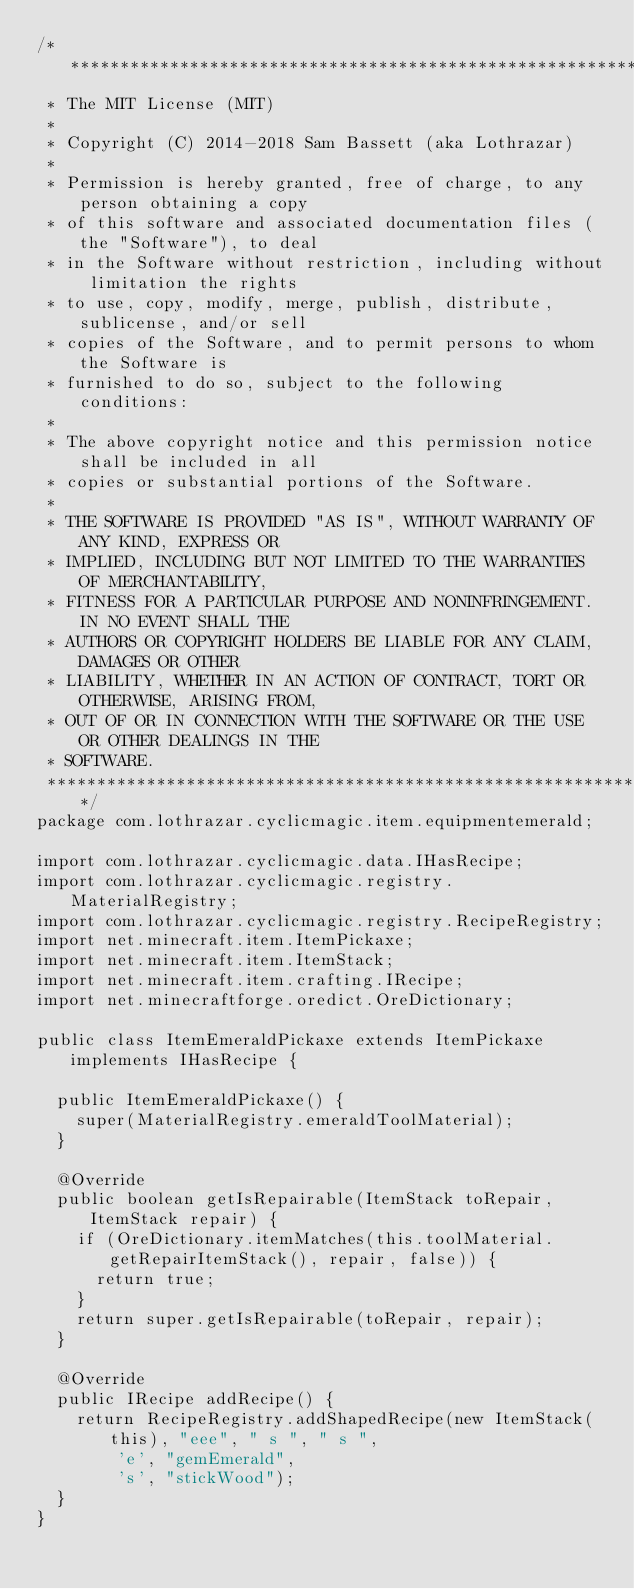Convert code to text. <code><loc_0><loc_0><loc_500><loc_500><_Java_>/*******************************************************************************
 * The MIT License (MIT)
 * 
 * Copyright (C) 2014-2018 Sam Bassett (aka Lothrazar)
 * 
 * Permission is hereby granted, free of charge, to any person obtaining a copy
 * of this software and associated documentation files (the "Software"), to deal
 * in the Software without restriction, including without limitation the rights
 * to use, copy, modify, merge, publish, distribute, sublicense, and/or sell
 * copies of the Software, and to permit persons to whom the Software is
 * furnished to do so, subject to the following conditions:
 * 
 * The above copyright notice and this permission notice shall be included in all
 * copies or substantial portions of the Software.
 * 
 * THE SOFTWARE IS PROVIDED "AS IS", WITHOUT WARRANTY OF ANY KIND, EXPRESS OR
 * IMPLIED, INCLUDING BUT NOT LIMITED TO THE WARRANTIES OF MERCHANTABILITY,
 * FITNESS FOR A PARTICULAR PURPOSE AND NONINFRINGEMENT. IN NO EVENT SHALL THE
 * AUTHORS OR COPYRIGHT HOLDERS BE LIABLE FOR ANY CLAIM, DAMAGES OR OTHER
 * LIABILITY, WHETHER IN AN ACTION OF CONTRACT, TORT OR OTHERWISE, ARISING FROM,
 * OUT OF OR IN CONNECTION WITH THE SOFTWARE OR THE USE OR OTHER DEALINGS IN THE
 * SOFTWARE.
 ******************************************************************************/
package com.lothrazar.cyclicmagic.item.equipmentemerald;

import com.lothrazar.cyclicmagic.data.IHasRecipe;
import com.lothrazar.cyclicmagic.registry.MaterialRegistry;
import com.lothrazar.cyclicmagic.registry.RecipeRegistry;
import net.minecraft.item.ItemPickaxe;
import net.minecraft.item.ItemStack;
import net.minecraft.item.crafting.IRecipe;
import net.minecraftforge.oredict.OreDictionary;

public class ItemEmeraldPickaxe extends ItemPickaxe implements IHasRecipe {

  public ItemEmeraldPickaxe() {
    super(MaterialRegistry.emeraldToolMaterial);
  }

  @Override
  public boolean getIsRepairable(ItemStack toRepair, ItemStack repair) {
    if (OreDictionary.itemMatches(this.toolMaterial.getRepairItemStack(), repair, false)) {
      return true;
    }
    return super.getIsRepairable(toRepair, repair);
  }

  @Override
  public IRecipe addRecipe() {
    return RecipeRegistry.addShapedRecipe(new ItemStack(this), "eee", " s ", " s ",
        'e', "gemEmerald",
        's', "stickWood");
  }
}
</code> 